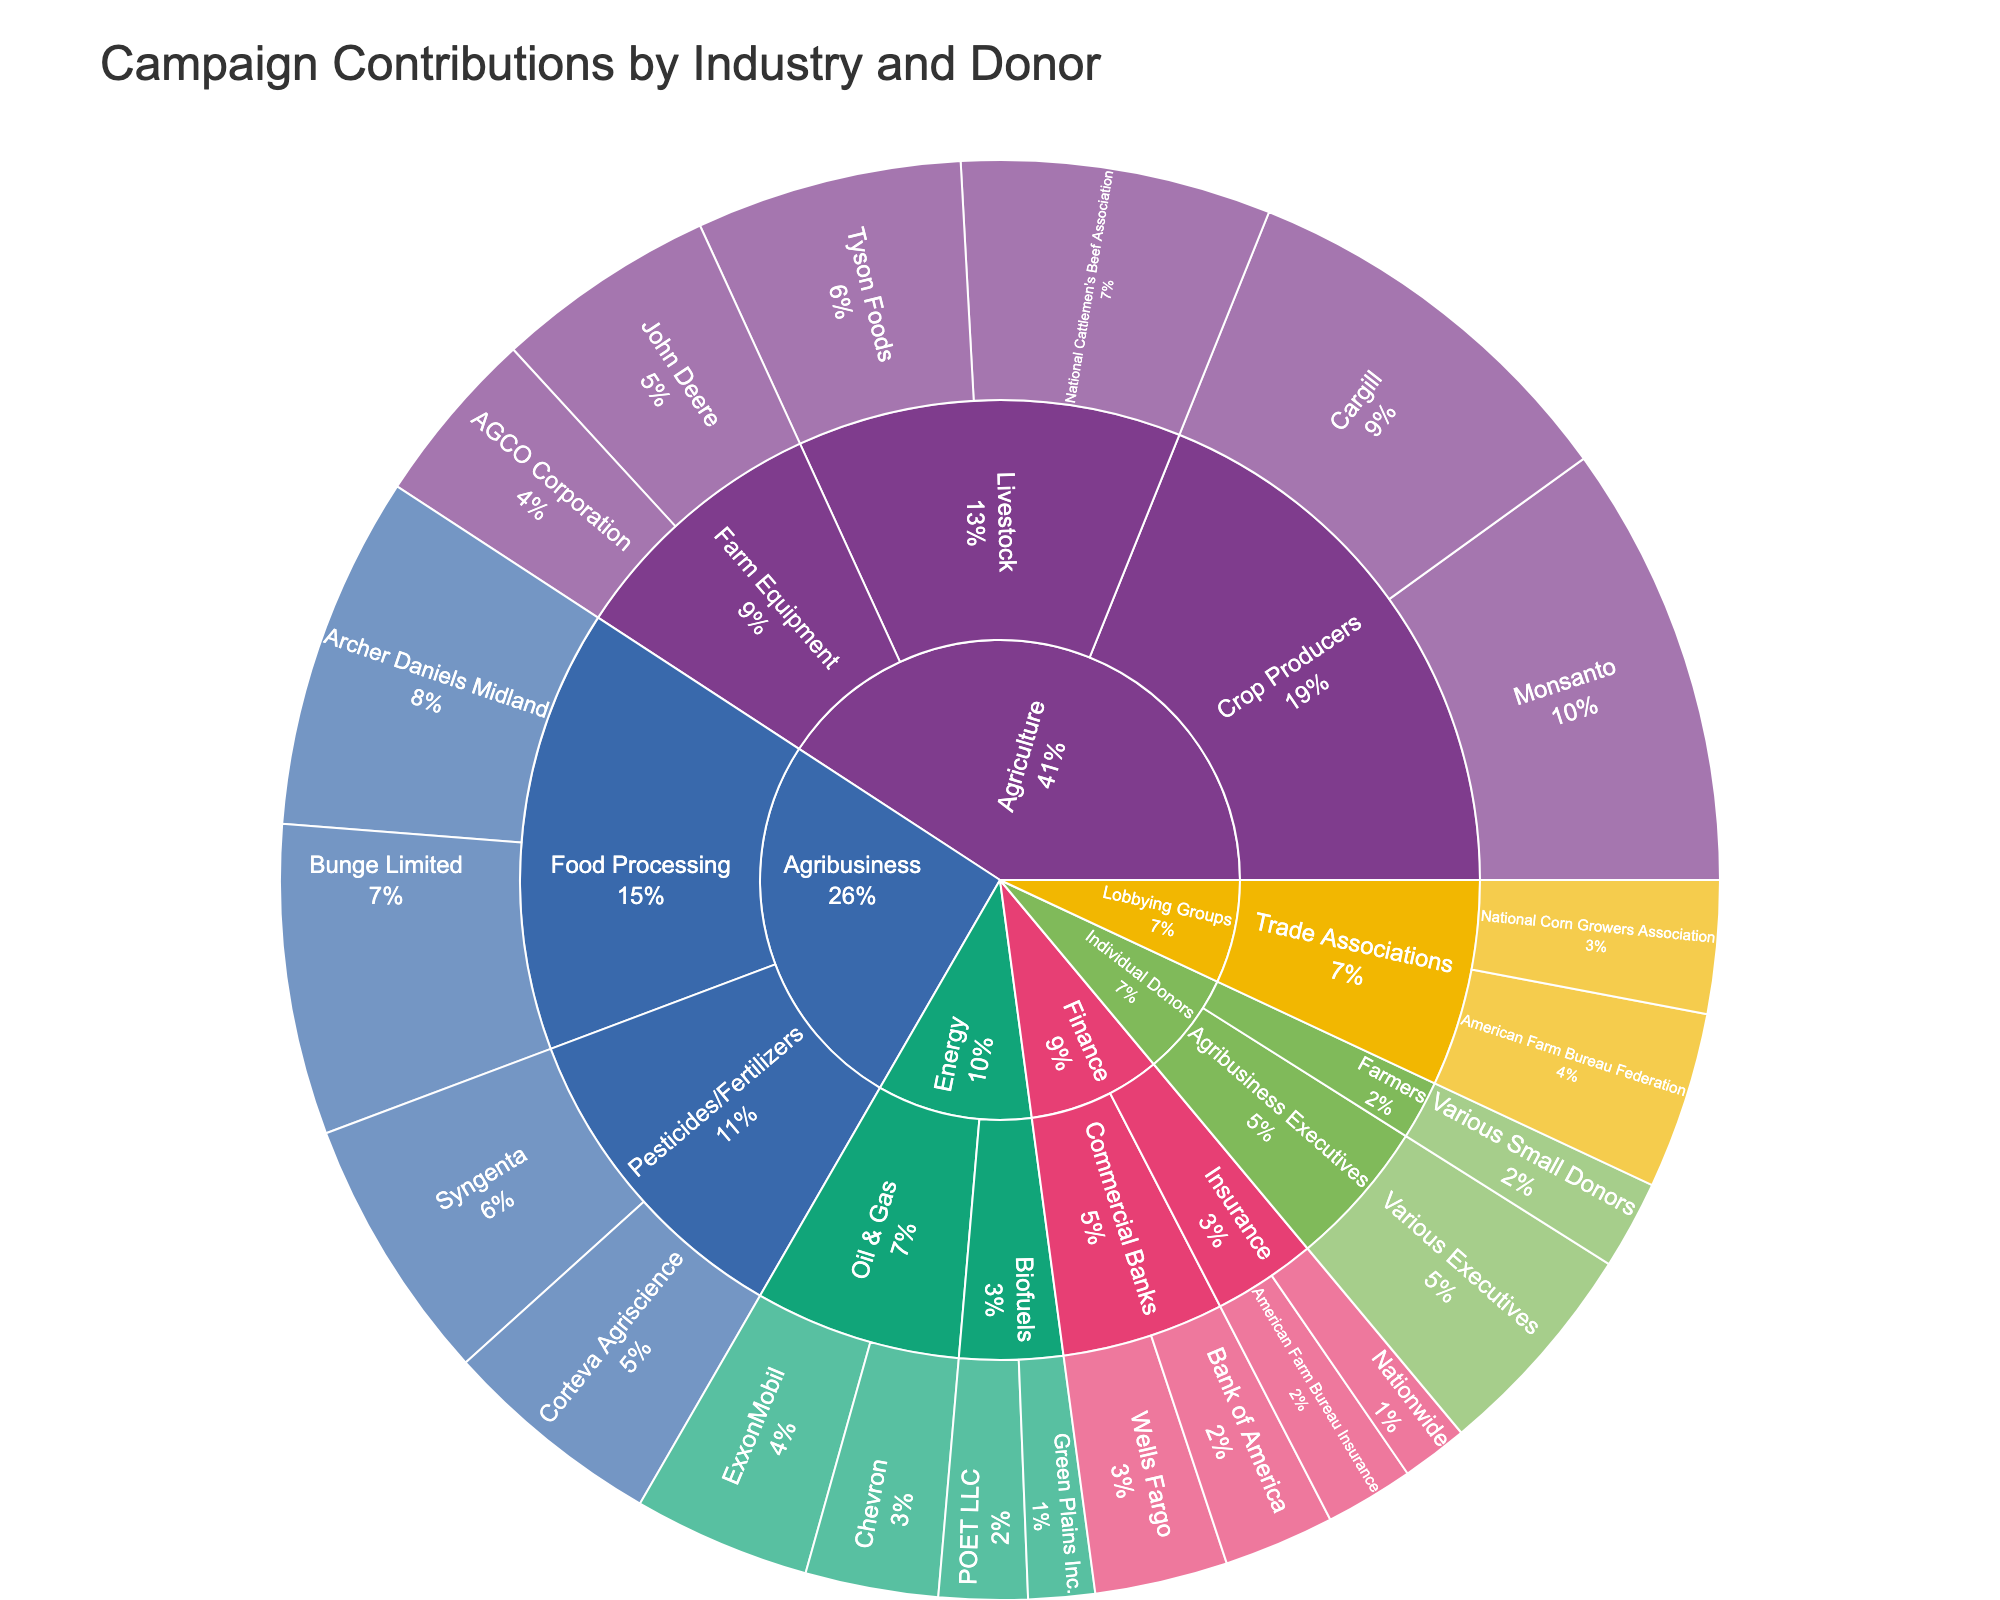Which category contributes the most? The largest section of the sunburst plot visually represents the category with the highest contributions. By inspecting the size of each category, we can determine the largest one.
Answer: Agriculture What are the total contributions from the 'Energy' category? Sum the amounts from all subcategories within the 'Energy' category: ExxonMobil ($200,000) + Chevron ($150,000) + POET LLC ($100,000) + Green Plains Inc. ($75,000) = $525,000.
Answer: $525,000 Which specific donor in the 'Agriculture' category has the highest contribution? Within the 'Agriculture' category, identify the donor with the largest section. Monsanto contributes $500,000, which is the highest among the donors in this category.
Answer: Monsanto Compare the contributions from 'Lobbying Groups' versus 'Individual Donors'. Which is higher? Sum the contributions from each group. For 'Lobbying Groups': American Farm Bureau Federation ($200,000) + National Corn Growers Association ($150,000) = $350,000. For 'Individual Donors': Various Small Donors ($100,000) + Various Executives ($250,000) = $350,000. Both are equal.
Answer: They are equal How much more does 'Agribusiness' contribute compared to 'Finance'? Calculate the total contributions of each and find the difference. 'Agribusiness': Archer Daniels Midland ($400,000) + Bunge Limited ($350,000) + Syngenta ($300,000) + Corteva Agriscience ($250,000) = $1,300,000. 'Finance': Wells Fargo ($150,000) + Bank of America ($125,000) + American Farm Bureau Insurance ($100,000) + Nationwide ($75,000) = $450,000. Difference: $1,300,000 - $450,000 = $850,000.
Answer: $850,000 What percentage of the contributions to pro-agricultural politicians come from 'Crop Producers'? Total contributions from 'Crop Producers': Monsanto ($500,000) + Cargill ($450,000) = $950,000. Total contributions overall: sum the amounts from all donors = $4,850,000. Percentage: ($950,000 / $4,850,000) * 100 ≈ 19.59%.
Answer: About 19.6% Which subcategory within 'Agribusiness' has the higher total contribution? Compare the summed contributions within each subcategory. 'Food Processing': Archer Daniels Midland ($400,000) + Bunge Limited ($350,000) = $750,000. 'Pesticides/Fertilizers': Syngenta ($300,000) + Corteva Agriscience ($250,000) = $550,000. Food Processing has a higher contribution.
Answer: Food Processing How do contributions from 'Farm Equipment' in 'Agriculture' compare with those from 'Oil & Gas' in 'Energy'? Sum contributions from each subcategory. 'Farm Equipment': John Deere ($250,000) + AGCO Corporation ($200,000) = $450,000. 'Oil & Gas': ExxonMobil ($200,000) + Chevron ($150,000) = $350,000. Farm Equipment contributes more.
Answer: Farm Equipment contributes more 